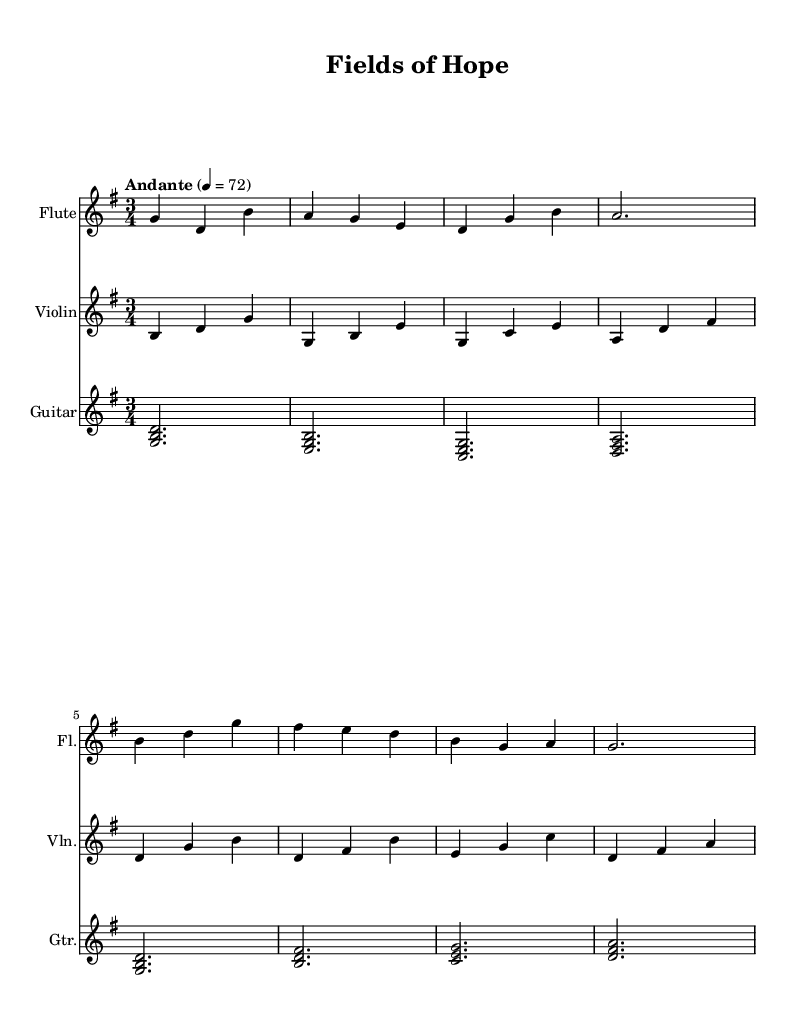What is the key signature of this music? The key signature is shown at the beginning of the staff, which indicates two sharps. This corresponds to the key of G major.
Answer: G major What is the time signature of this music? The time signature is located after the key signature and indicates three beats per measure. This is written as 3/4.
Answer: 3/4 What is the tempo marking for this piece? The tempo marking, typically found above the staff, indicates the speed of the music. In this piece, it is marked "Andante" at a metronome marking of 72, indicating a moderately slow pace.
Answer: Andante, 72 How many measures are in the flute part? Counting the distinct groupings of notes (measures), we find that the flute part contains eight measures in total.
Answer: 8 Which instruments are featured in this score? The instruments are listed at the beginning of each staff. The score features three instruments: Flute, Violin, and Guitar.
Answer: Flute, Violin, Guitar Which note serves as the first note in the violin part? The first note in the violin part is indicated by the notation on the staff. Upon reviewing, it is a B note in the second octave.
Answer: B What chord is played in the first measure of the guitar part? The first measure of the guitar part shows three notes stacked vertically in a simultaneous fashion, which indicates a chord. The notes are G, B, and D, forming a G major chord.
Answer: G major 